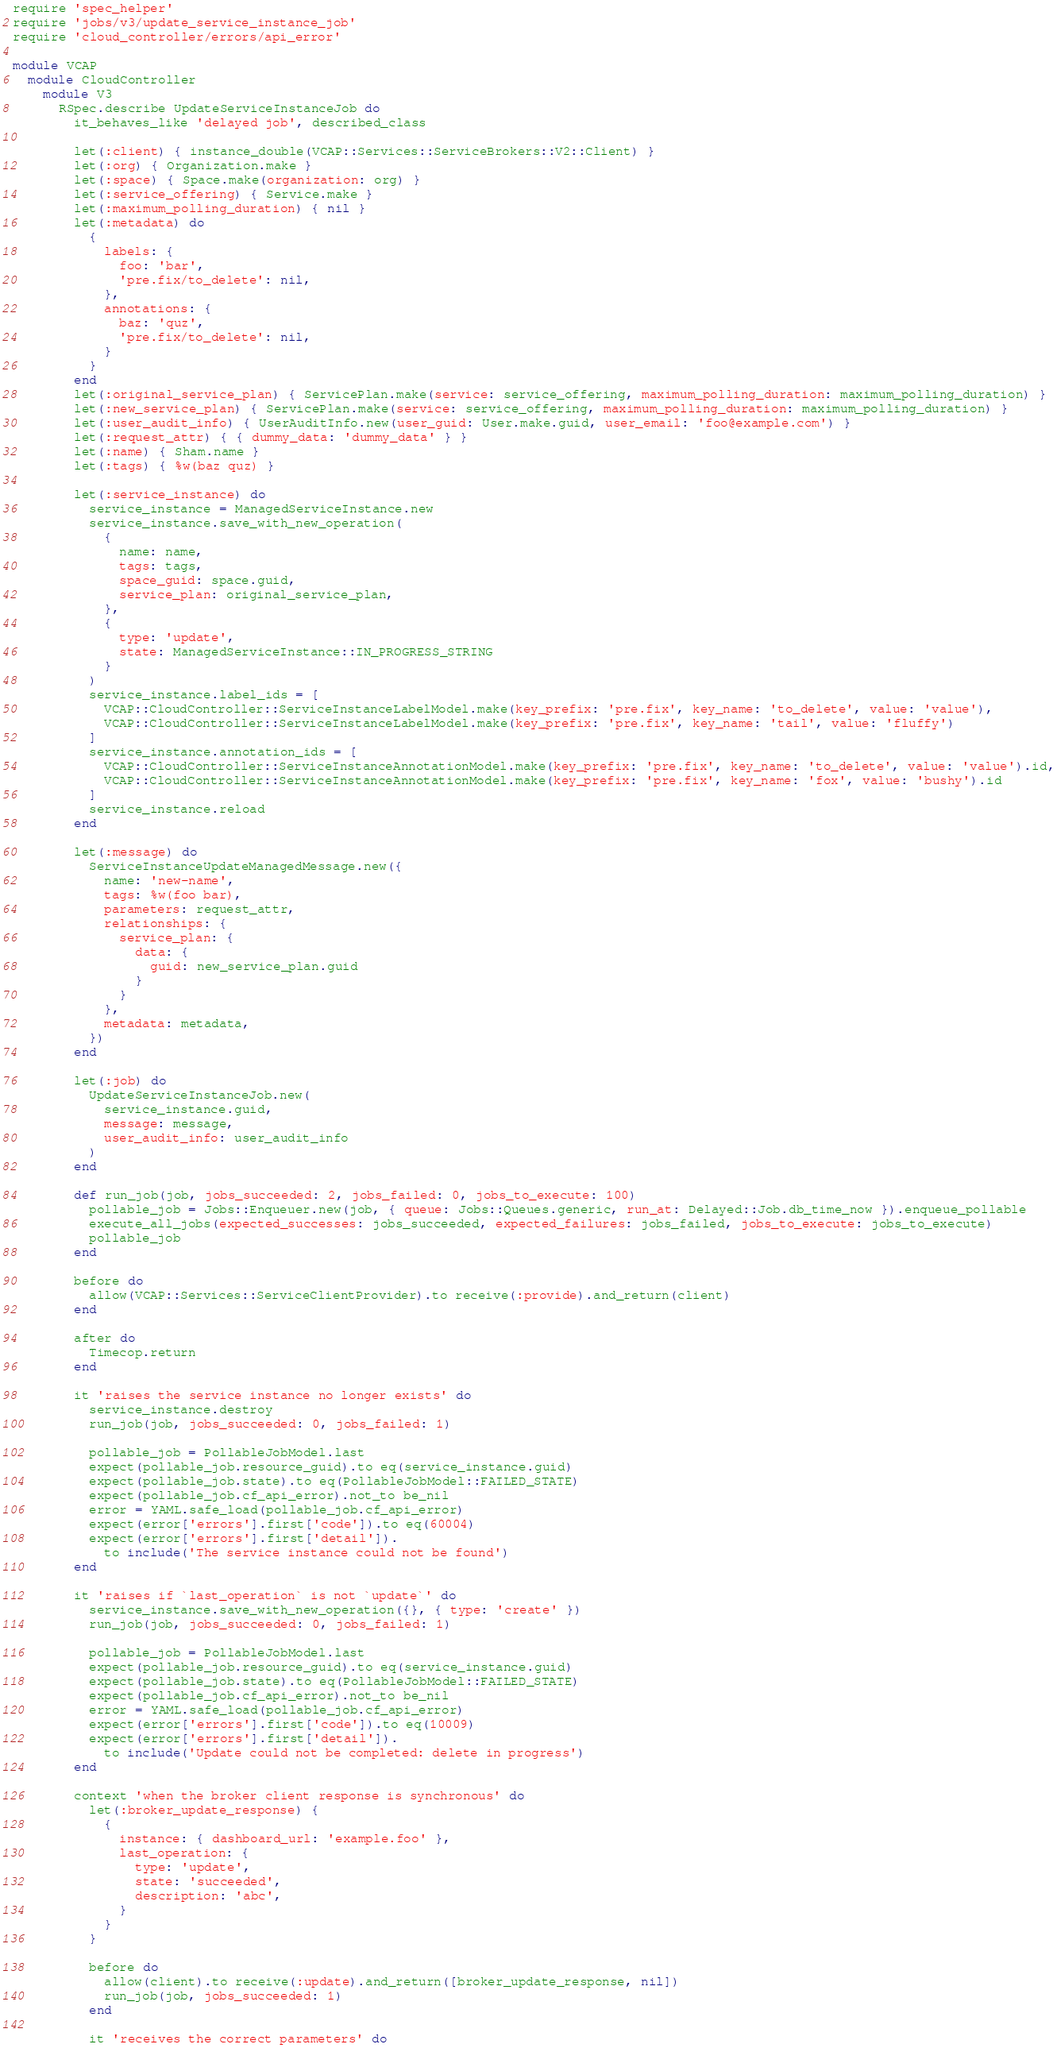Convert code to text. <code><loc_0><loc_0><loc_500><loc_500><_Ruby_>require 'spec_helper'
require 'jobs/v3/update_service_instance_job'
require 'cloud_controller/errors/api_error'

module VCAP
  module CloudController
    module V3
      RSpec.describe UpdateServiceInstanceJob do
        it_behaves_like 'delayed job', described_class

        let(:client) { instance_double(VCAP::Services::ServiceBrokers::V2::Client) }
        let(:org) { Organization.make }
        let(:space) { Space.make(organization: org) }
        let(:service_offering) { Service.make }
        let(:maximum_polling_duration) { nil }
        let(:metadata) do
          {
            labels: {
              foo: 'bar',
              'pre.fix/to_delete': nil,
            },
            annotations: {
              baz: 'quz',
              'pre.fix/to_delete': nil,
            }
          }
        end
        let(:original_service_plan) { ServicePlan.make(service: service_offering, maximum_polling_duration: maximum_polling_duration) }
        let(:new_service_plan) { ServicePlan.make(service: service_offering, maximum_polling_duration: maximum_polling_duration) }
        let(:user_audit_info) { UserAuditInfo.new(user_guid: User.make.guid, user_email: 'foo@example.com') }
        let(:request_attr) { { dummy_data: 'dummy_data' } }
        let(:name) { Sham.name }
        let(:tags) { %w(baz quz) }

        let(:service_instance) do
          service_instance = ManagedServiceInstance.new
          service_instance.save_with_new_operation(
            {
              name: name,
              tags: tags,
              space_guid: space.guid,
              service_plan: original_service_plan,
            },
            {
              type: 'update',
              state: ManagedServiceInstance::IN_PROGRESS_STRING
            }
          )
          service_instance.label_ids = [
            VCAP::CloudController::ServiceInstanceLabelModel.make(key_prefix: 'pre.fix', key_name: 'to_delete', value: 'value'),
            VCAP::CloudController::ServiceInstanceLabelModel.make(key_prefix: 'pre.fix', key_name: 'tail', value: 'fluffy')
          ]
          service_instance.annotation_ids = [
            VCAP::CloudController::ServiceInstanceAnnotationModel.make(key_prefix: 'pre.fix', key_name: 'to_delete', value: 'value').id,
            VCAP::CloudController::ServiceInstanceAnnotationModel.make(key_prefix: 'pre.fix', key_name: 'fox', value: 'bushy').id
          ]
          service_instance.reload
        end

        let(:message) do
          ServiceInstanceUpdateManagedMessage.new({
            name: 'new-name',
            tags: %w(foo bar),
            parameters: request_attr,
            relationships: {
              service_plan: {
                data: {
                  guid: new_service_plan.guid
                }
              }
            },
            metadata: metadata,
          })
        end

        let(:job) do
          UpdateServiceInstanceJob.new(
            service_instance.guid,
            message: message,
            user_audit_info: user_audit_info
          )
        end

        def run_job(job, jobs_succeeded: 2, jobs_failed: 0, jobs_to_execute: 100)
          pollable_job = Jobs::Enqueuer.new(job, { queue: Jobs::Queues.generic, run_at: Delayed::Job.db_time_now }).enqueue_pollable
          execute_all_jobs(expected_successes: jobs_succeeded, expected_failures: jobs_failed, jobs_to_execute: jobs_to_execute)
          pollable_job
        end

        before do
          allow(VCAP::Services::ServiceClientProvider).to receive(:provide).and_return(client)
        end

        after do
          Timecop.return
        end

        it 'raises the service instance no longer exists' do
          service_instance.destroy
          run_job(job, jobs_succeeded: 0, jobs_failed: 1)

          pollable_job = PollableJobModel.last
          expect(pollable_job.resource_guid).to eq(service_instance.guid)
          expect(pollable_job.state).to eq(PollableJobModel::FAILED_STATE)
          expect(pollable_job.cf_api_error).not_to be_nil
          error = YAML.safe_load(pollable_job.cf_api_error)
          expect(error['errors'].first['code']).to eq(60004)
          expect(error['errors'].first['detail']).
            to include('The service instance could not be found')
        end

        it 'raises if `last_operation` is not `update`' do
          service_instance.save_with_new_operation({}, { type: 'create' })
          run_job(job, jobs_succeeded: 0, jobs_failed: 1)

          pollable_job = PollableJobModel.last
          expect(pollable_job.resource_guid).to eq(service_instance.guid)
          expect(pollable_job.state).to eq(PollableJobModel::FAILED_STATE)
          expect(pollable_job.cf_api_error).not_to be_nil
          error = YAML.safe_load(pollable_job.cf_api_error)
          expect(error['errors'].first['code']).to eq(10009)
          expect(error['errors'].first['detail']).
            to include('Update could not be completed: delete in progress')
        end

        context 'when the broker client response is synchronous' do
          let(:broker_update_response) {
            {
              instance: { dashboard_url: 'example.foo' },
              last_operation: {
                type: 'update',
                state: 'succeeded',
                description: 'abc',
              }
            }
          }

          before do
            allow(client).to receive(:update).and_return([broker_update_response, nil])
            run_job(job, jobs_succeeded: 1)
          end

          it 'receives the correct parameters' do</code> 